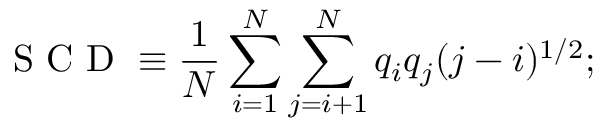Convert formula to latex. <formula><loc_0><loc_0><loc_500><loc_500>S C D \equiv \frac { 1 } { N } \sum _ { i = 1 } ^ { N } \sum _ { j = i + 1 } ^ { N } q _ { i } q _ { j } ( j - i ) ^ { 1 / 2 } ;</formula> 